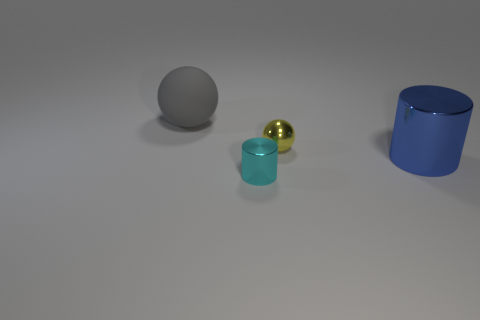What size is the ball right of the matte object?
Your answer should be compact. Small. Are there any gray matte objects that have the same size as the gray rubber sphere?
Provide a succinct answer. No. There is a shiny cylinder that is behind the cyan cylinder; is it the same size as the cyan metallic cylinder?
Provide a succinct answer. No. How big is the yellow metal thing?
Your answer should be compact. Small. There is a big thing in front of the large thing that is behind the small metal thing on the right side of the tiny cylinder; what is its color?
Keep it short and to the point. Blue. There is a small sphere to the left of the large metallic thing; is it the same color as the large matte sphere?
Give a very brief answer. No. How many big objects are behind the small yellow object and to the right of the yellow ball?
Your response must be concise. 0. The gray matte object that is the same shape as the yellow object is what size?
Your answer should be very brief. Large. There is a large gray sphere behind the ball that is right of the rubber sphere; how many large blue cylinders are left of it?
Offer a terse response. 0. There is a metal thing in front of the large object on the right side of the tiny cylinder; what color is it?
Your response must be concise. Cyan. 